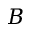Convert formula to latex. <formula><loc_0><loc_0><loc_500><loc_500>B</formula> 